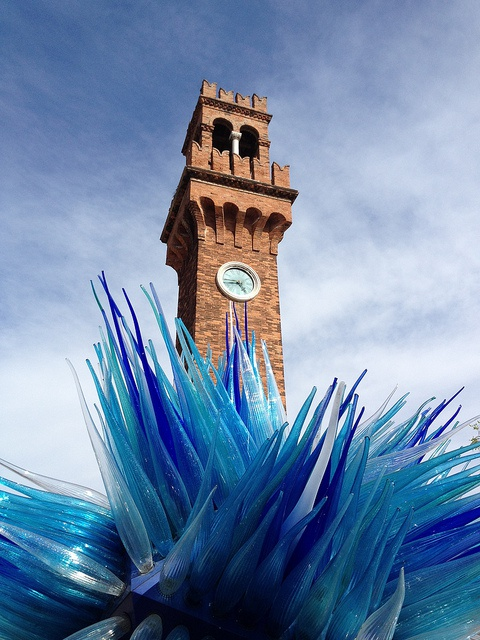Describe the objects in this image and their specific colors. I can see a clock in gray, ivory, darkgray, and lightblue tones in this image. 